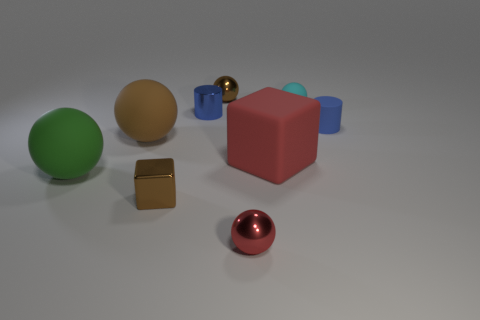There is a red ball that is made of the same material as the tiny cube; what size is it?
Your answer should be very brief. Small. Is the number of red matte blocks less than the number of small cylinders?
Offer a very short reply. Yes. There is a brown cube that is the same size as the metallic cylinder; what is it made of?
Ensure brevity in your answer.  Metal. Are there more tiny yellow matte objects than blue matte cylinders?
Your response must be concise. No. How many other objects are there of the same color as the tiny metallic cylinder?
Keep it short and to the point. 1. What number of things are both to the left of the rubber cylinder and behind the big green rubber sphere?
Keep it short and to the point. 5. Is the number of tiny metal spheres that are in front of the matte cylinder greater than the number of small blocks left of the big green matte ball?
Give a very brief answer. Yes. There is a tiny brown object on the right side of the brown shiny cube; what material is it?
Provide a short and direct response. Metal. Do the big red rubber thing and the small brown metal object that is in front of the large block have the same shape?
Provide a short and direct response. Yes. There is a big matte ball right of the rubber sphere in front of the large cube; what number of balls are left of it?
Offer a terse response. 1. 